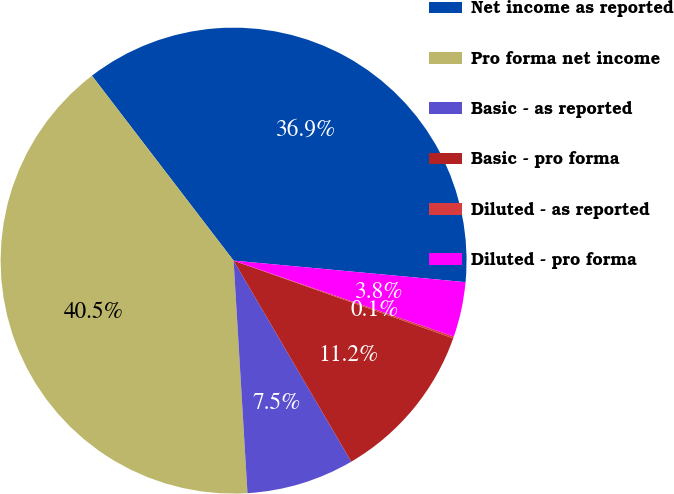Convert chart to OTSL. <chart><loc_0><loc_0><loc_500><loc_500><pie_chart><fcel>Net income as reported<fcel>Pro forma net income<fcel>Basic - as reported<fcel>Basic - pro forma<fcel>Diluted - as reported<fcel>Diluted - pro forma<nl><fcel>36.88%<fcel>40.55%<fcel>7.48%<fcel>11.16%<fcel>0.13%<fcel>3.81%<nl></chart> 